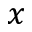Convert formula to latex. <formula><loc_0><loc_0><loc_500><loc_500>x</formula> 